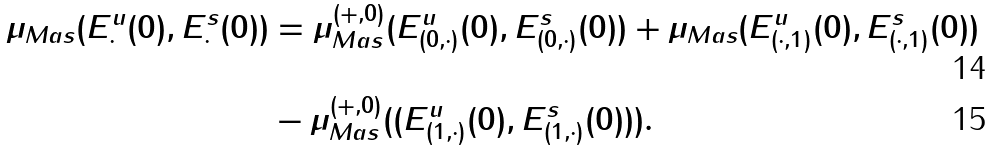Convert formula to latex. <formula><loc_0><loc_0><loc_500><loc_500>\mu _ { M a s } ( E ^ { u } _ { \cdot } ( 0 ) , E ^ { s } _ { \cdot } ( 0 ) ) & = \mu ^ { ( + , 0 ) } _ { M a s } ( E ^ { u } _ { ( 0 , \cdot ) } ( 0 ) , E ^ { s } _ { ( 0 , \cdot ) } ( 0 ) ) + \mu _ { M a s } ( E ^ { u } _ { ( \cdot , 1 ) } ( 0 ) , E ^ { s } _ { ( \cdot , 1 ) } ( 0 ) ) \\ & - \mu ^ { ( + , 0 ) } _ { M a s } ( ( E ^ { u } _ { ( 1 , \cdot ) } ( 0 ) , E ^ { s } _ { ( 1 , \cdot ) } ( 0 ) ) ) .</formula> 